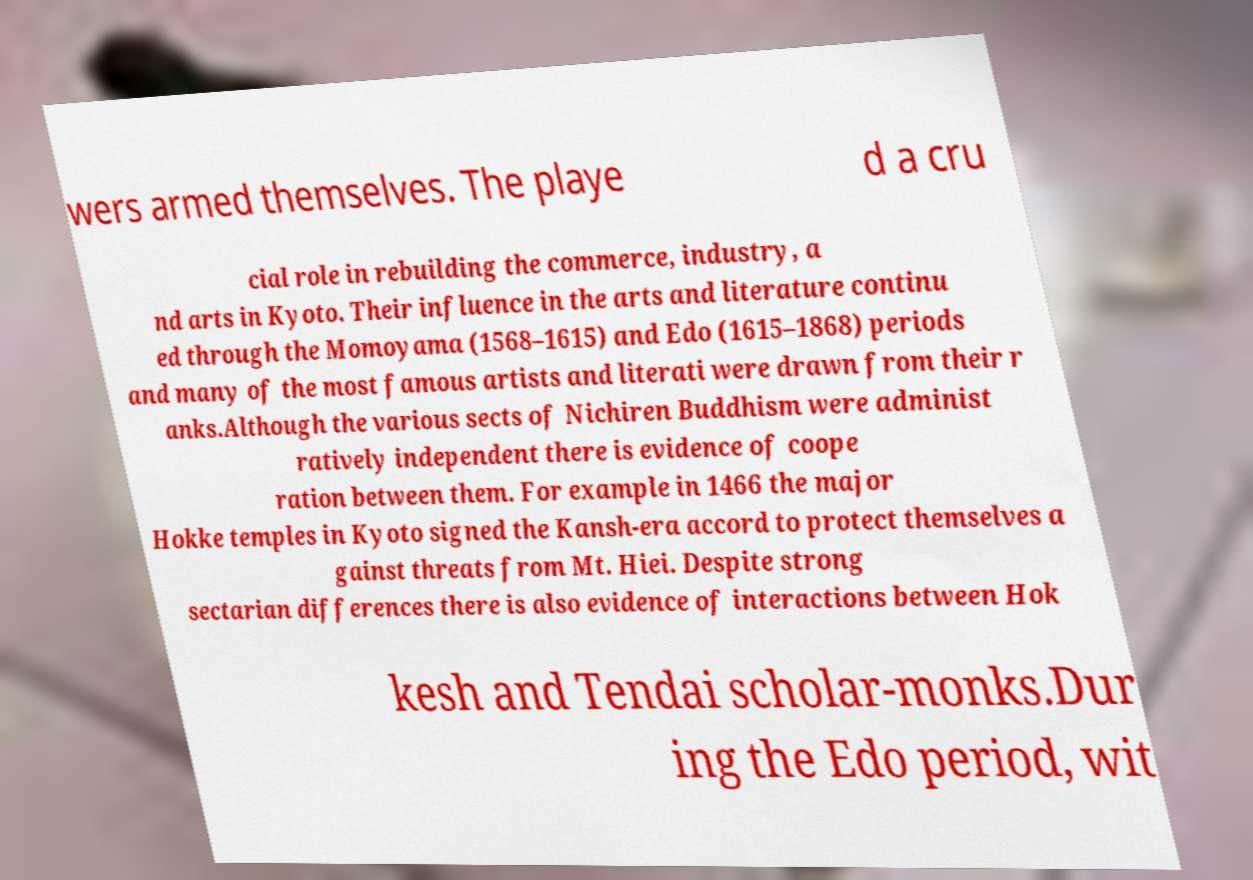Could you extract and type out the text from this image? wers armed themselves. The playe d a cru cial role in rebuilding the commerce, industry, a nd arts in Kyoto. Their influence in the arts and literature continu ed through the Momoyama (1568–1615) and Edo (1615–1868) periods and many of the most famous artists and literati were drawn from their r anks.Although the various sects of Nichiren Buddhism were administ ratively independent there is evidence of coope ration between them. For example in 1466 the major Hokke temples in Kyoto signed the Kansh-era accord to protect themselves a gainst threats from Mt. Hiei. Despite strong sectarian differences there is also evidence of interactions between Hok kesh and Tendai scholar-monks.Dur ing the Edo period, wit 